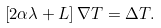Convert formula to latex. <formula><loc_0><loc_0><loc_500><loc_500>\left [ 2 \alpha \lambda + L \right ] \nabla T = \Delta T .</formula> 